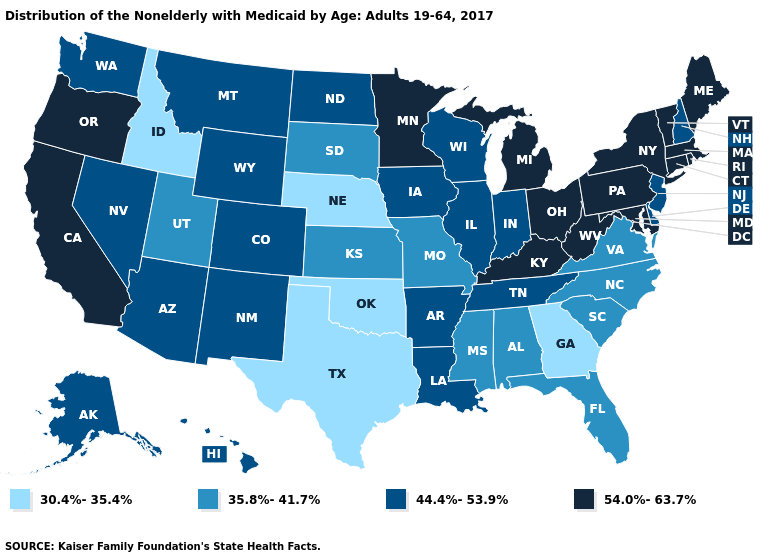Which states have the lowest value in the USA?
Quick response, please. Georgia, Idaho, Nebraska, Oklahoma, Texas. What is the value of Vermont?
Write a very short answer. 54.0%-63.7%. Does Alabama have a lower value than Pennsylvania?
Quick response, please. Yes. Does Missouri have a lower value than New Jersey?
Quick response, please. Yes. What is the value of Oregon?
Concise answer only. 54.0%-63.7%. Name the states that have a value in the range 44.4%-53.9%?
Short answer required. Alaska, Arizona, Arkansas, Colorado, Delaware, Hawaii, Illinois, Indiana, Iowa, Louisiana, Montana, Nevada, New Hampshire, New Jersey, New Mexico, North Dakota, Tennessee, Washington, Wisconsin, Wyoming. Name the states that have a value in the range 30.4%-35.4%?
Answer briefly. Georgia, Idaho, Nebraska, Oklahoma, Texas. Does Virginia have the lowest value in the USA?
Short answer required. No. Name the states that have a value in the range 30.4%-35.4%?
Write a very short answer. Georgia, Idaho, Nebraska, Oklahoma, Texas. What is the highest value in the USA?
Give a very brief answer. 54.0%-63.7%. What is the value of Montana?
Give a very brief answer. 44.4%-53.9%. Name the states that have a value in the range 30.4%-35.4%?
Give a very brief answer. Georgia, Idaho, Nebraska, Oklahoma, Texas. Which states have the highest value in the USA?
Answer briefly. California, Connecticut, Kentucky, Maine, Maryland, Massachusetts, Michigan, Minnesota, New York, Ohio, Oregon, Pennsylvania, Rhode Island, Vermont, West Virginia. Does South Dakota have a higher value than Maryland?
Keep it brief. No. Does the map have missing data?
Write a very short answer. No. 